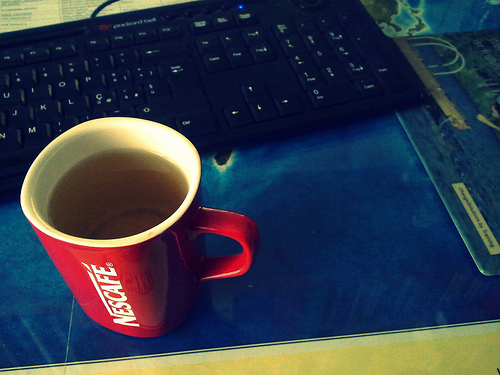<image>
Is the mug under the keyboard? No. The mug is not positioned under the keyboard. The vertical relationship between these objects is different. Is the cup next to the keyboard? Yes. The cup is positioned adjacent to the keyboard, located nearby in the same general area. 